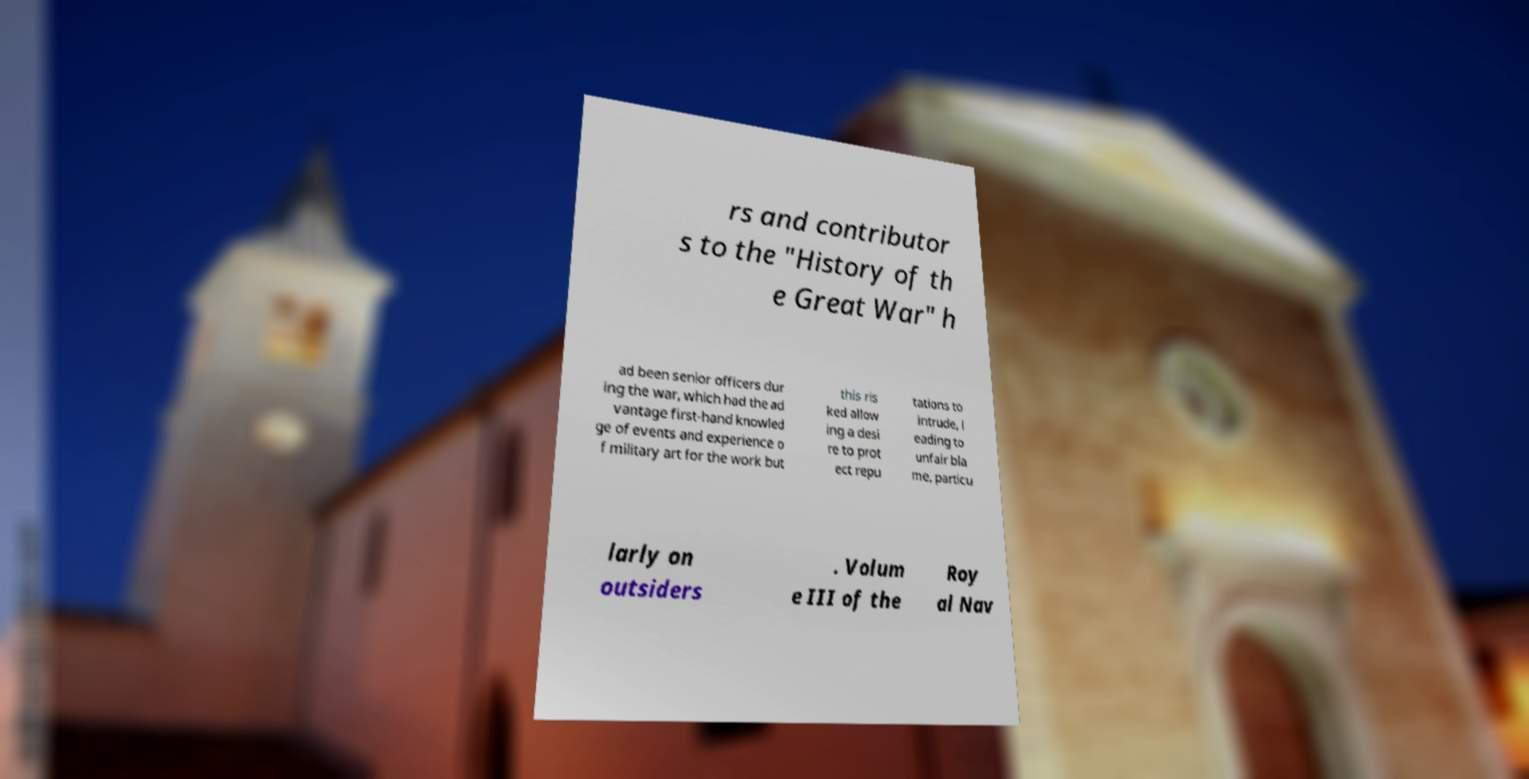Please read and relay the text visible in this image. What does it say? rs and contributor s to the "History of th e Great War" h ad been senior officers dur ing the war, which had the ad vantage first-hand knowled ge of events and experience o f military art for the work but this ris ked allow ing a desi re to prot ect repu tations to intrude, l eading to unfair bla me, particu larly on outsiders . Volum e III of the Roy al Nav 